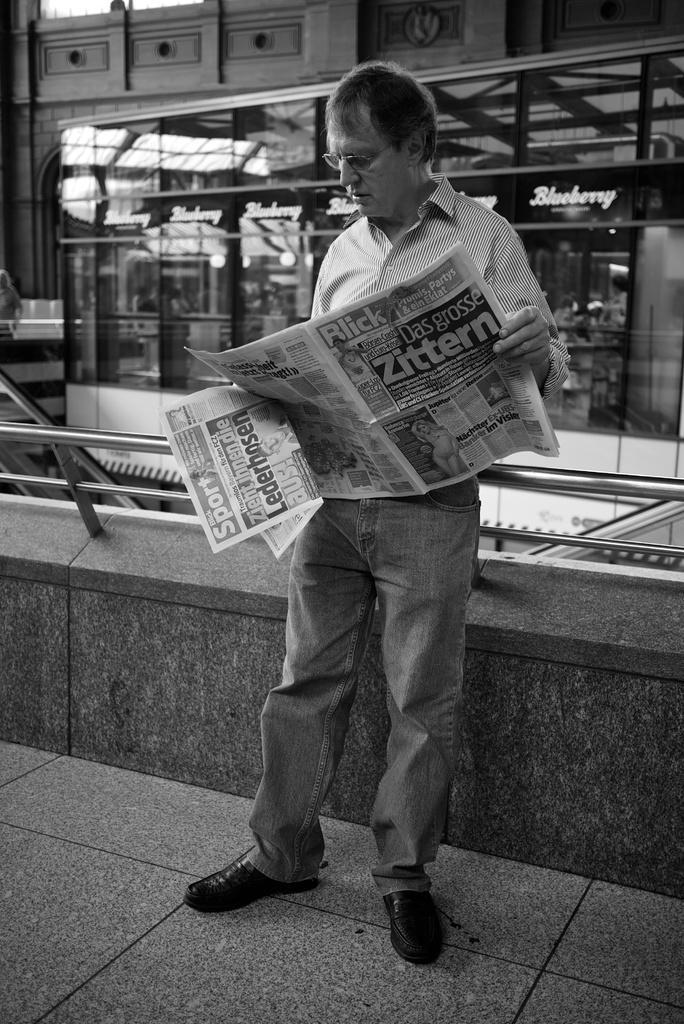How would you summarize this image in a sentence or two? In this picture there is a person standing and holding the paper. At the back there is a building and there is a railing on the wall. At the bottom there is a floor. 